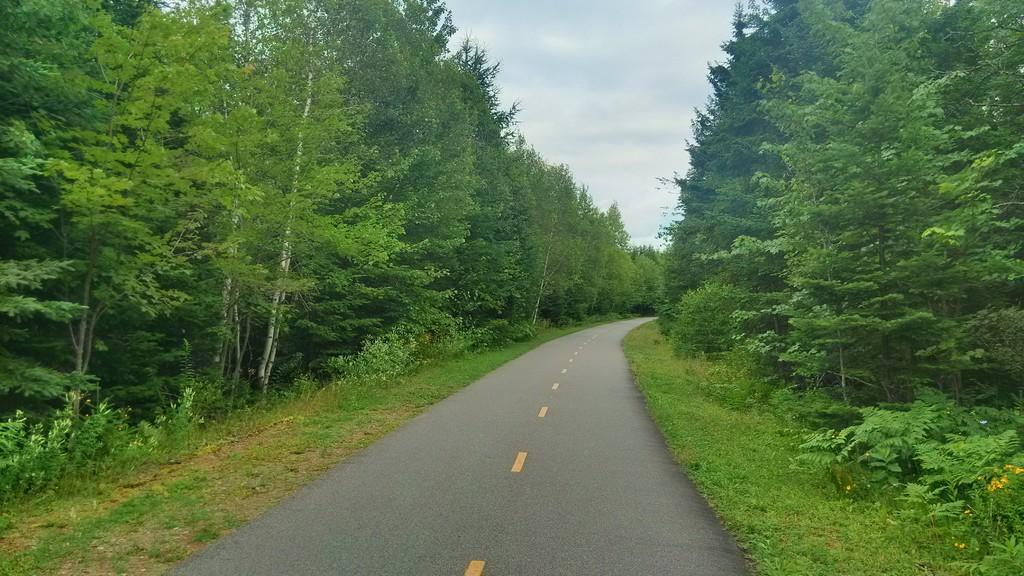Can you describe this image briefly? This picture shows few trees and we see a road and grass on the ground and a blue cloudy sky. 